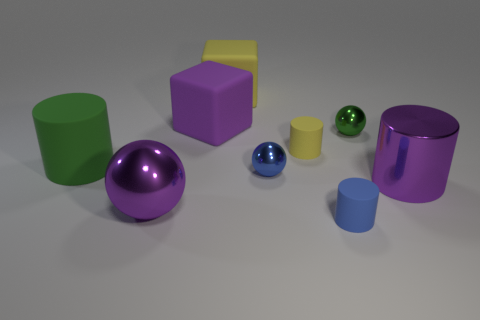Subtract all big purple shiny spheres. How many spheres are left? 2 Subtract all green cylinders. How many cylinders are left? 3 Subtract all cylinders. How many objects are left? 5 Subtract all big green rubber cylinders. Subtract all yellow matte things. How many objects are left? 6 Add 8 green matte objects. How many green matte objects are left? 9 Add 7 big purple matte objects. How many big purple matte objects exist? 8 Subtract 1 purple cubes. How many objects are left? 8 Subtract all yellow cylinders. Subtract all cyan cubes. How many cylinders are left? 3 